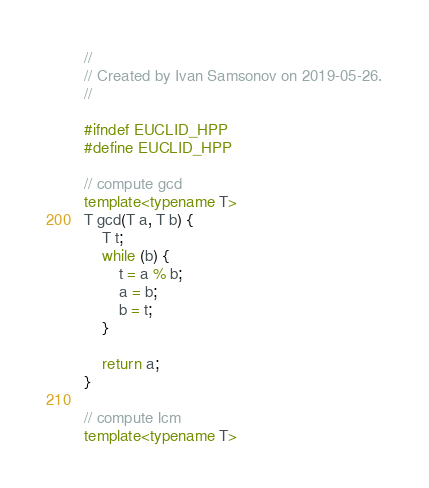<code> <loc_0><loc_0><loc_500><loc_500><_C++_>//
// Created by Ivan Samsonov on 2019-05-26.
//

#ifndef EUCLID_HPP
#define EUCLID_HPP

// compute gcd
template<typename T>
T gcd(T a, T b) {
    T t;
    while (b) {
        t = a % b;
        a = b;
        b = t;
    }

    return a;
}

// compute lcm
template<typename T></code> 